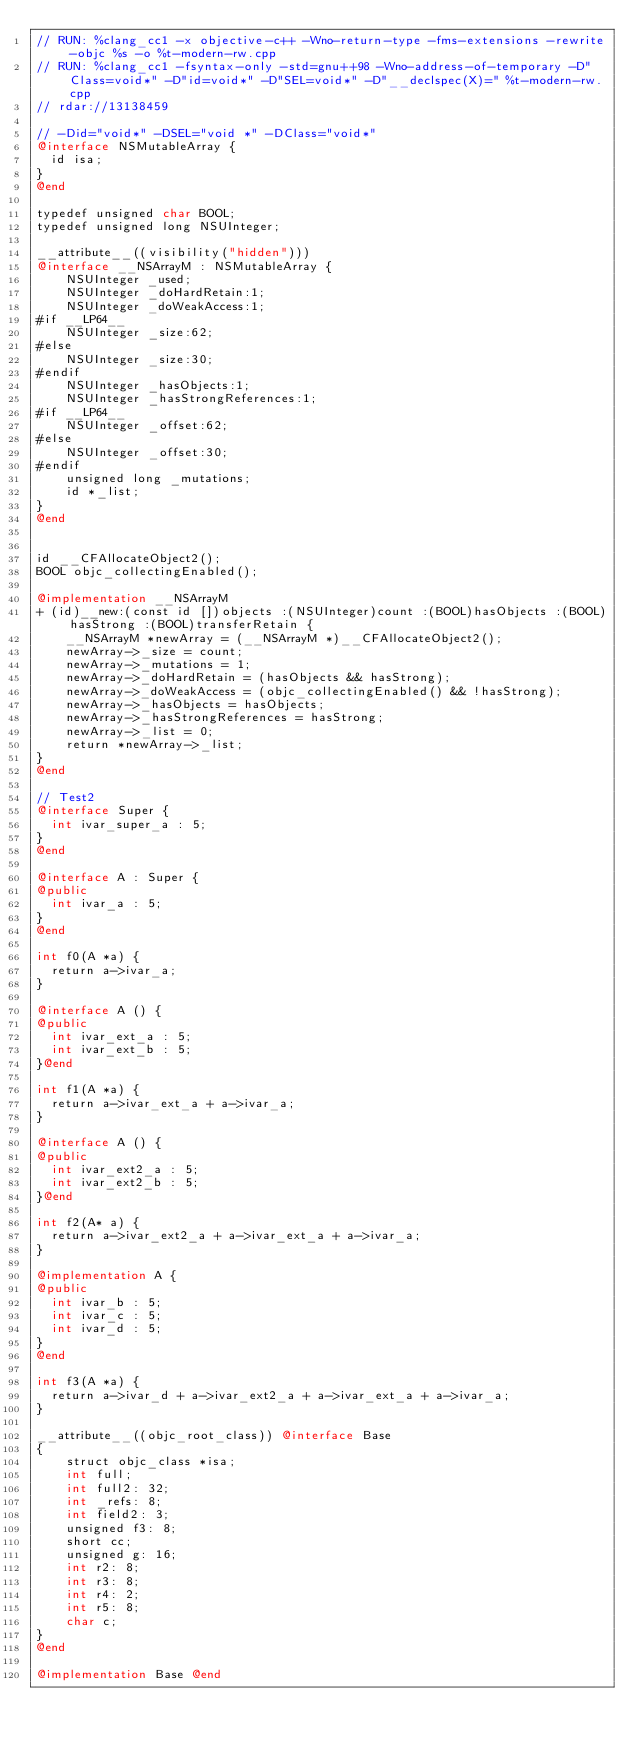<code> <loc_0><loc_0><loc_500><loc_500><_ObjectiveC_>// RUN: %clang_cc1 -x objective-c++ -Wno-return-type -fms-extensions -rewrite-objc %s -o %t-modern-rw.cpp
// RUN: %clang_cc1 -fsyntax-only -std=gnu++98 -Wno-address-of-temporary -D"Class=void*" -D"id=void*" -D"SEL=void*" -D"__declspec(X)=" %t-modern-rw.cpp
// rdar://13138459

// -Did="void*" -DSEL="void *" -DClass="void*"
@interface NSMutableArray {
  id isa;
}
@end

typedef unsigned char BOOL;
typedef unsigned long NSUInteger;

__attribute__((visibility("hidden")))
@interface __NSArrayM : NSMutableArray {
    NSUInteger _used;
    NSUInteger _doHardRetain:1;
    NSUInteger _doWeakAccess:1;
#if __LP64__
    NSUInteger _size:62;
#else
    NSUInteger _size:30;
#endif
    NSUInteger _hasObjects:1;
    NSUInteger _hasStrongReferences:1;
#if __LP64__
    NSUInteger _offset:62;
#else
    NSUInteger _offset:30;
#endif
    unsigned long _mutations;
    id *_list;
}
@end


id __CFAllocateObject2();
BOOL objc_collectingEnabled();

@implementation __NSArrayM
+ (id)__new:(const id [])objects :(NSUInteger)count :(BOOL)hasObjects :(BOOL)hasStrong :(BOOL)transferRetain {
    __NSArrayM *newArray = (__NSArrayM *)__CFAllocateObject2();
    newArray->_size = count;
    newArray->_mutations = 1;
    newArray->_doHardRetain = (hasObjects && hasStrong);
    newArray->_doWeakAccess = (objc_collectingEnabled() && !hasStrong);
    newArray->_hasObjects = hasObjects;
    newArray->_hasStrongReferences = hasStrong;
    newArray->_list = 0;
    return *newArray->_list;
}
@end

// Test2
@interface Super {
  int ivar_super_a : 5;
}
@end

@interface A : Super {
@public
  int ivar_a : 5;
}
@end

int f0(A *a) {
  return a->ivar_a;
}

@interface A () {
@public
  int ivar_ext_a : 5;
  int ivar_ext_b : 5;
}@end

int f1(A *a) {
  return a->ivar_ext_a + a->ivar_a;
}

@interface A () {
@public
  int ivar_ext2_a : 5;
  int ivar_ext2_b : 5;
}@end

int f2(A* a) {
  return a->ivar_ext2_a + a->ivar_ext_a + a->ivar_a;
}

@implementation A {
@public
  int ivar_b : 5;
  int ivar_c : 5;
  int ivar_d : 5;
}
@end

int f3(A *a) {  
  return a->ivar_d + a->ivar_ext2_a + a->ivar_ext_a + a->ivar_a;
}

__attribute__((objc_root_class)) @interface Base
{
    struct objc_class *isa;
    int full;
    int full2: 32;
    int _refs: 8;
    int field2: 3;
    unsigned f3: 8;
    short cc;
    unsigned g: 16;
    int r2: 8;
    int r3: 8;
    int r4: 2;
    int r5: 8;
    char c;
}
@end

@implementation Base @end
</code> 